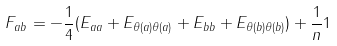<formula> <loc_0><loc_0><loc_500><loc_500>F _ { a b } = - \frac { 1 } { 4 } ( E _ { a a } + E _ { \theta ( a ) \theta ( a ) } + E _ { b b } + E _ { \theta ( b ) \theta ( b ) } ) + \frac { 1 } { n } 1</formula> 